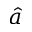Convert formula to latex. <formula><loc_0><loc_0><loc_500><loc_500>\hat { a }</formula> 